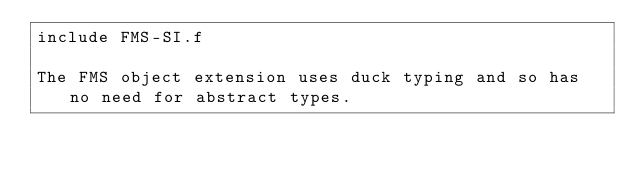Convert code to text. <code><loc_0><loc_0><loc_500><loc_500><_Forth_>include FMS-SI.f

The FMS object extension uses duck typing and so has no need for abstract types.
</code> 